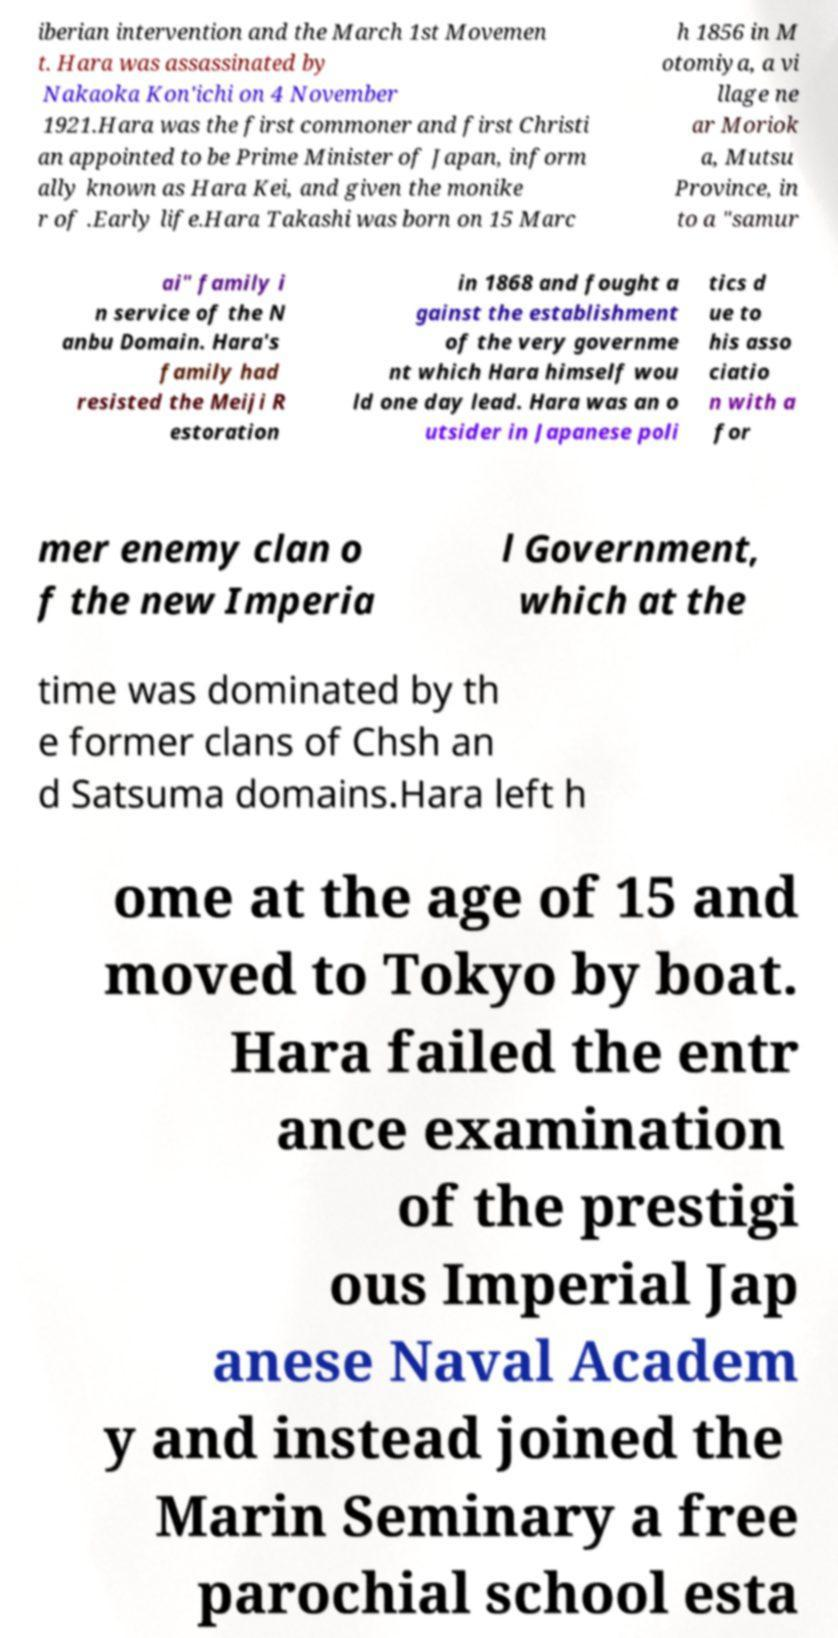Could you extract and type out the text from this image? iberian intervention and the March 1st Movemen t. Hara was assassinated by Nakaoka Kon'ichi on 4 November 1921.Hara was the first commoner and first Christi an appointed to be Prime Minister of Japan, inform ally known as Hara Kei, and given the monike r of .Early life.Hara Takashi was born on 15 Marc h 1856 in M otomiya, a vi llage ne ar Moriok a, Mutsu Province, in to a "samur ai" family i n service of the N anbu Domain. Hara's family had resisted the Meiji R estoration in 1868 and fought a gainst the establishment of the very governme nt which Hara himself wou ld one day lead. Hara was an o utsider in Japanese poli tics d ue to his asso ciatio n with a for mer enemy clan o f the new Imperia l Government, which at the time was dominated by th e former clans of Chsh an d Satsuma domains.Hara left h ome at the age of 15 and moved to Tokyo by boat. Hara failed the entr ance examination of the prestigi ous Imperial Jap anese Naval Academ y and instead joined the Marin Seminary a free parochial school esta 